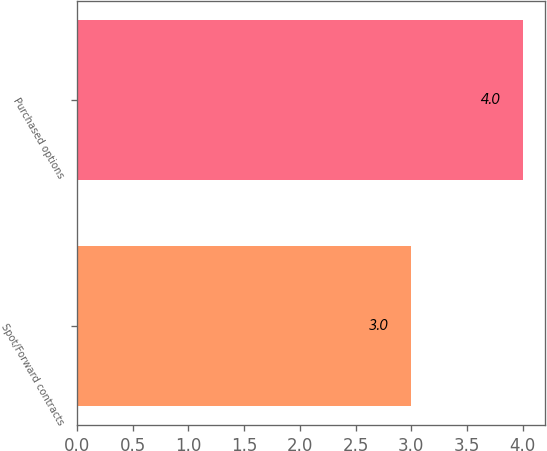Convert chart to OTSL. <chart><loc_0><loc_0><loc_500><loc_500><bar_chart><fcel>Spot/Forward contracts<fcel>Purchased options<nl><fcel>3<fcel>4<nl></chart> 